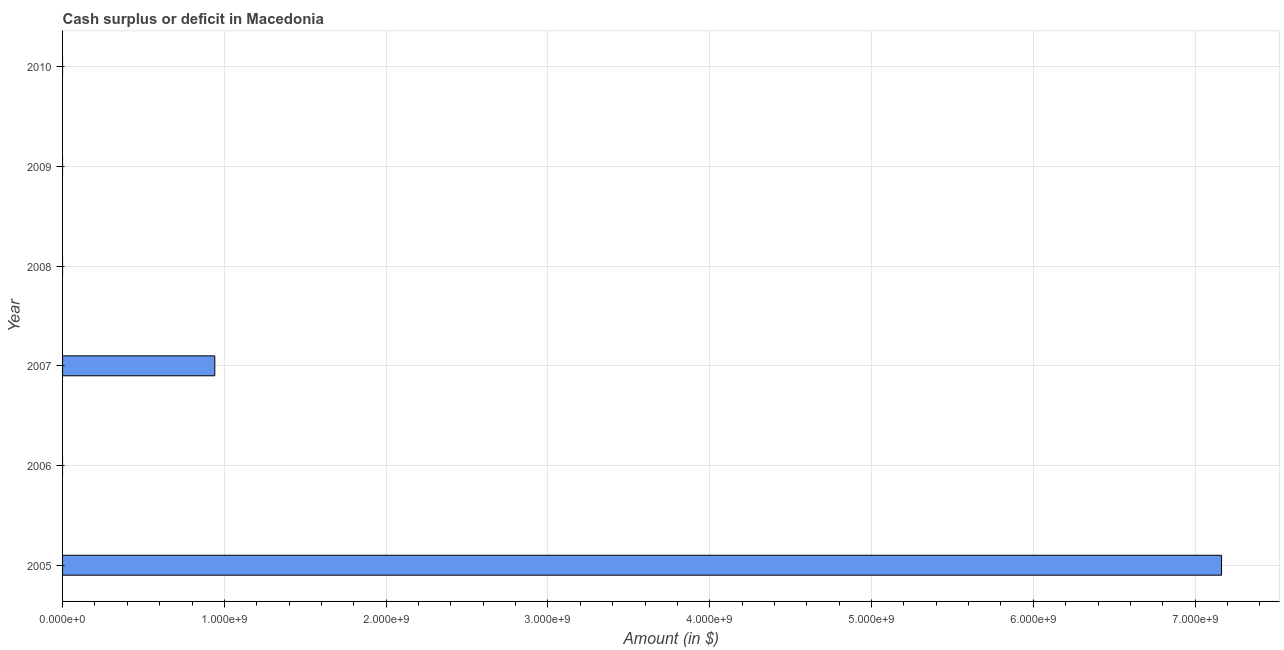What is the title of the graph?
Provide a succinct answer. Cash surplus or deficit in Macedonia. What is the label or title of the X-axis?
Your response must be concise. Amount (in $). What is the label or title of the Y-axis?
Make the answer very short. Year. Across all years, what is the maximum cash surplus or deficit?
Make the answer very short. 7.16e+09. In which year was the cash surplus or deficit maximum?
Your answer should be very brief. 2005. What is the sum of the cash surplus or deficit?
Provide a succinct answer. 8.10e+09. What is the average cash surplus or deficit per year?
Your response must be concise. 1.35e+09. What is the median cash surplus or deficit?
Offer a terse response. 0. What is the ratio of the cash surplus or deficit in 2005 to that in 2007?
Your answer should be very brief. 7.61. What is the difference between the highest and the lowest cash surplus or deficit?
Give a very brief answer. 7.16e+09. Are all the bars in the graph horizontal?
Offer a terse response. Yes. What is the Amount (in $) of 2005?
Ensure brevity in your answer.  7.16e+09. What is the Amount (in $) of 2006?
Ensure brevity in your answer.  0. What is the Amount (in $) of 2007?
Ensure brevity in your answer.  9.41e+08. What is the difference between the Amount (in $) in 2005 and 2007?
Offer a terse response. 6.22e+09. What is the ratio of the Amount (in $) in 2005 to that in 2007?
Provide a succinct answer. 7.61. 